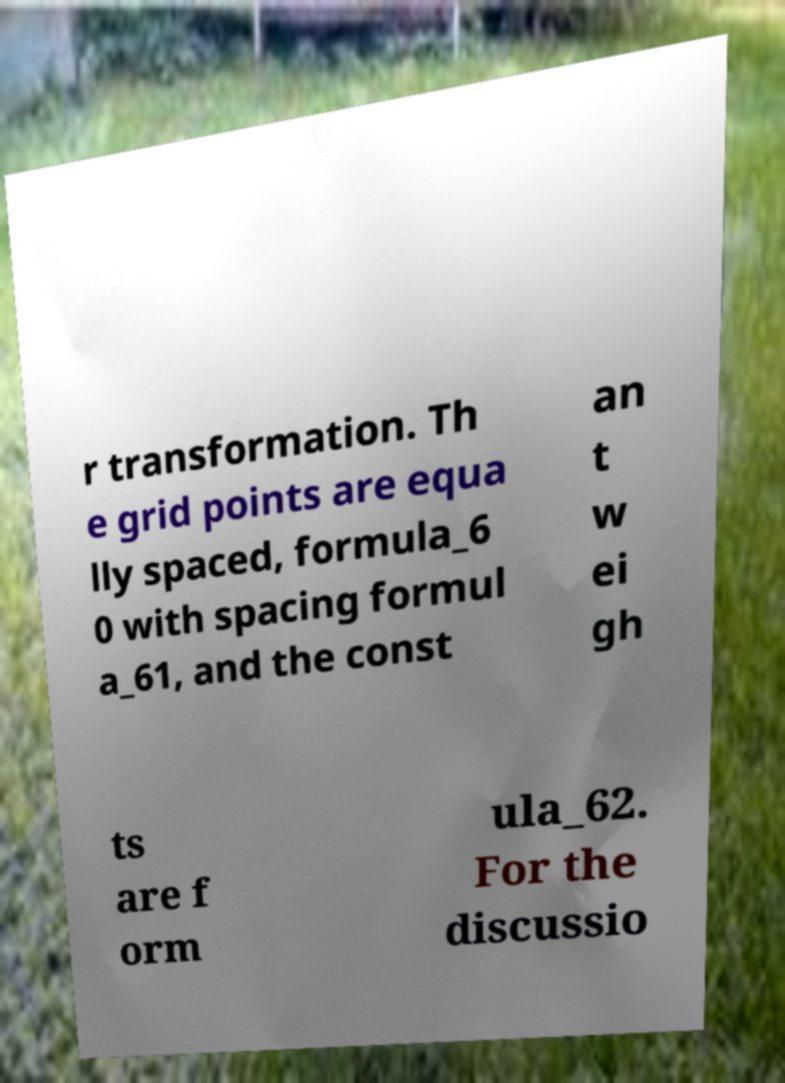Could you extract and type out the text from this image? r transformation. Th e grid points are equa lly spaced, formula_6 0 with spacing formul a_61, and the const an t w ei gh ts are f orm ula_62. For the discussio 